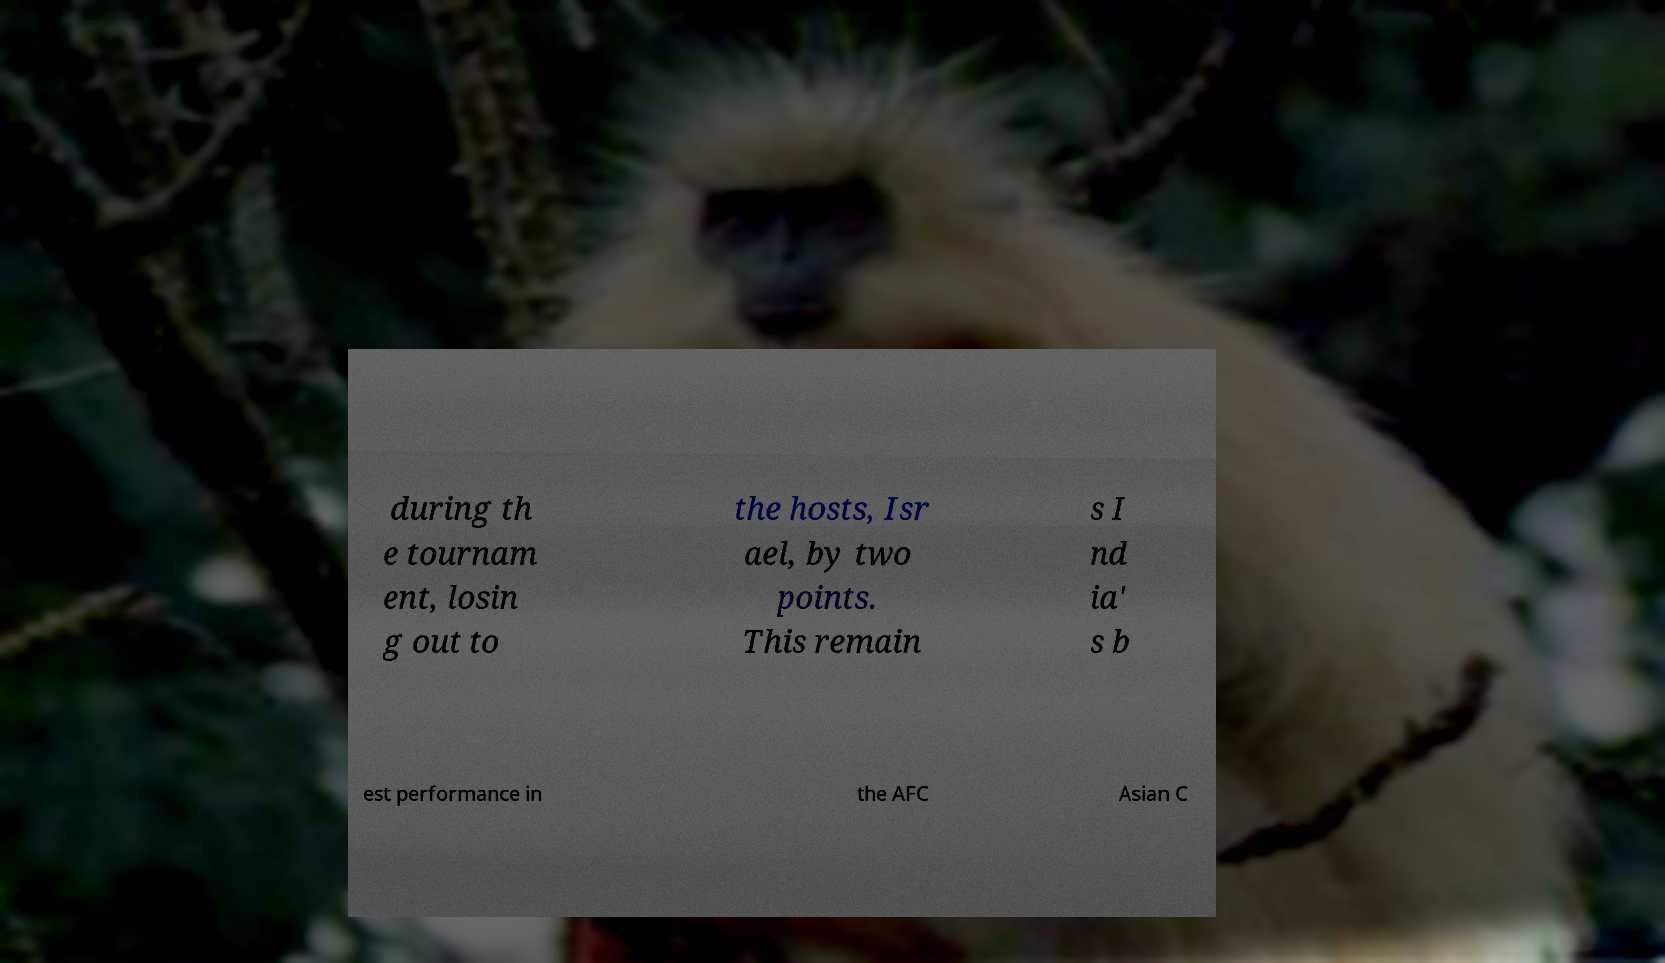Please identify and transcribe the text found in this image. during th e tournam ent, losin g out to the hosts, Isr ael, by two points. This remain s I nd ia' s b est performance in the AFC Asian C 